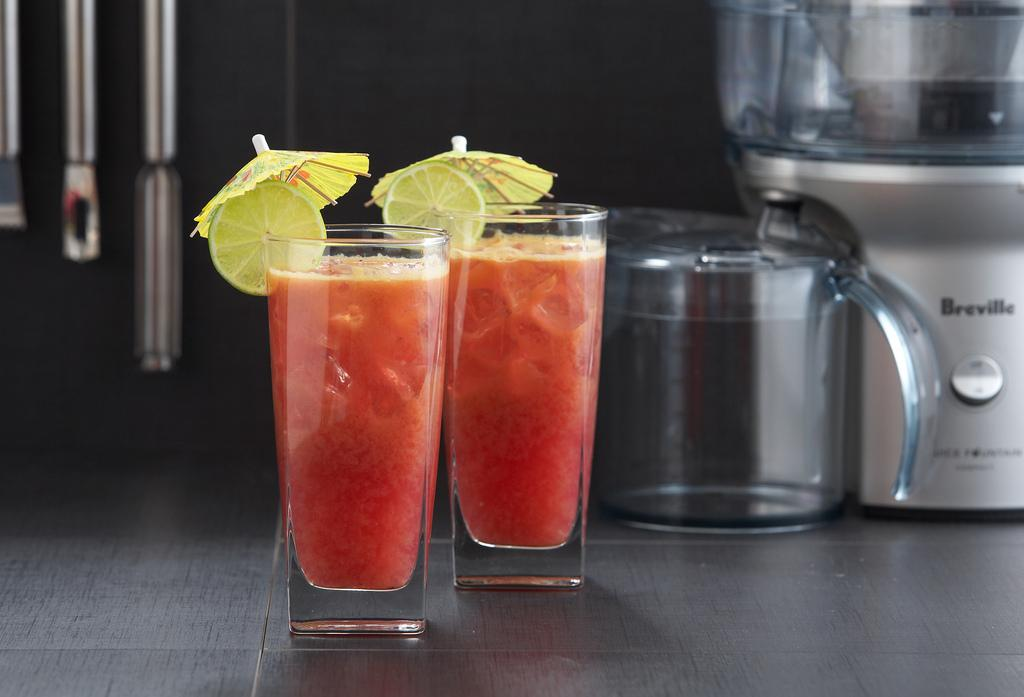<image>
Offer a succinct explanation of the picture presented. Two mixed drinks were prepared probably by using the Breville blender to the right. 